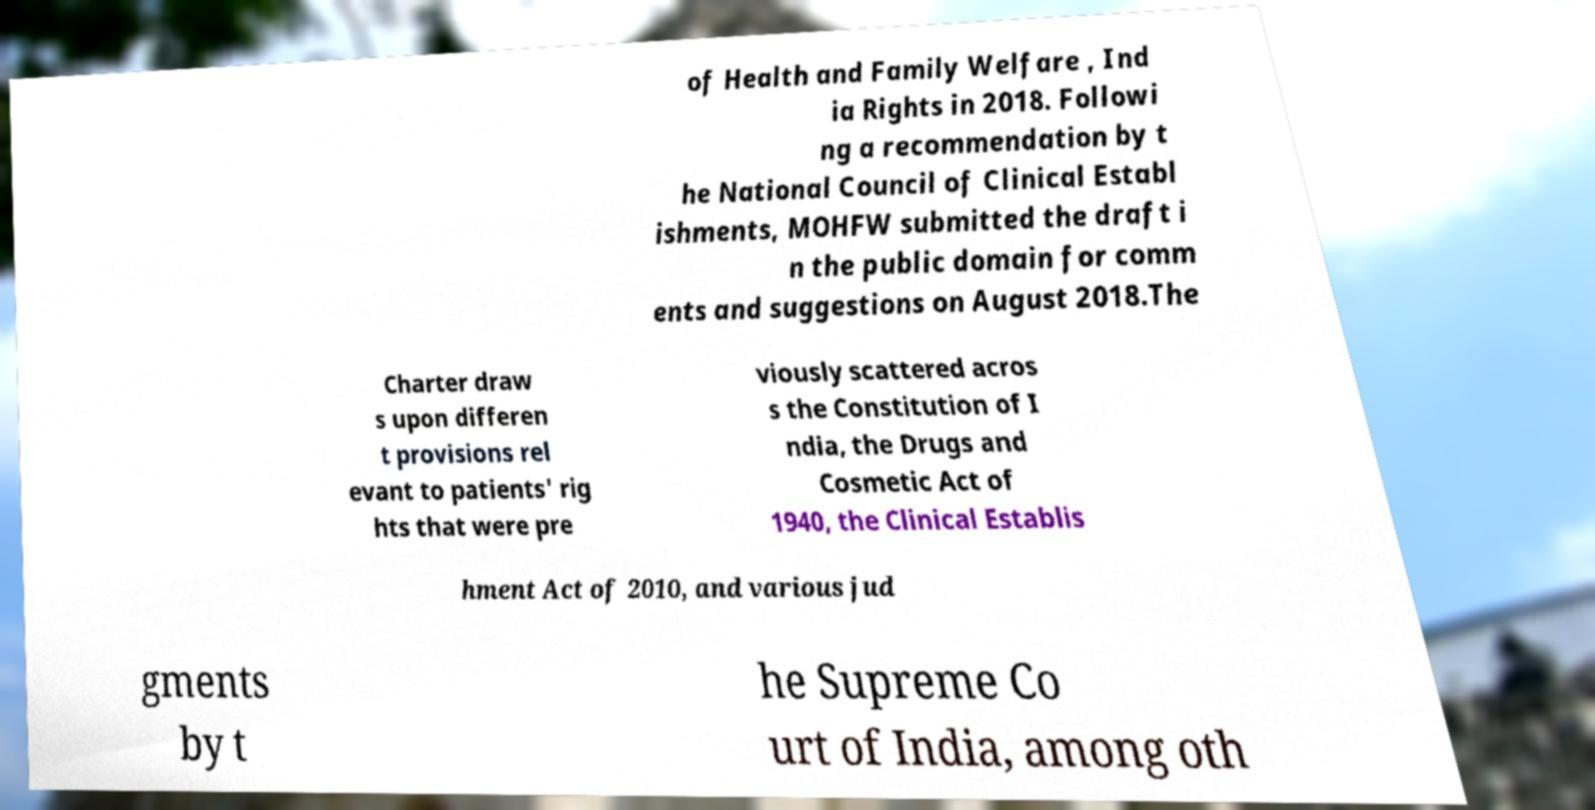Could you extract and type out the text from this image? of Health and Family Welfare , Ind ia Rights in 2018. Followi ng a recommendation by t he National Council of Clinical Establ ishments, MOHFW submitted the draft i n the public domain for comm ents and suggestions on August 2018.The Charter draw s upon differen t provisions rel evant to patients' rig hts that were pre viously scattered acros s the Constitution of I ndia, the Drugs and Cosmetic Act of 1940, the Clinical Establis hment Act of 2010, and various jud gments by t he Supreme Co urt of India, among oth 